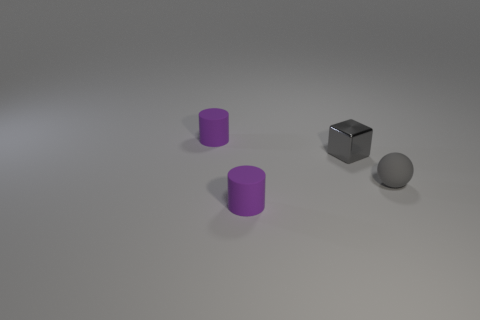Add 1 small rubber objects. How many objects exist? 5 Subtract all balls. How many objects are left? 3 Add 3 purple matte cylinders. How many purple matte cylinders are left? 5 Add 1 large yellow matte spheres. How many large yellow matte spheres exist? 1 Subtract 0 purple spheres. How many objects are left? 4 Subtract all purple matte cylinders. Subtract all small purple matte cylinders. How many objects are left? 0 